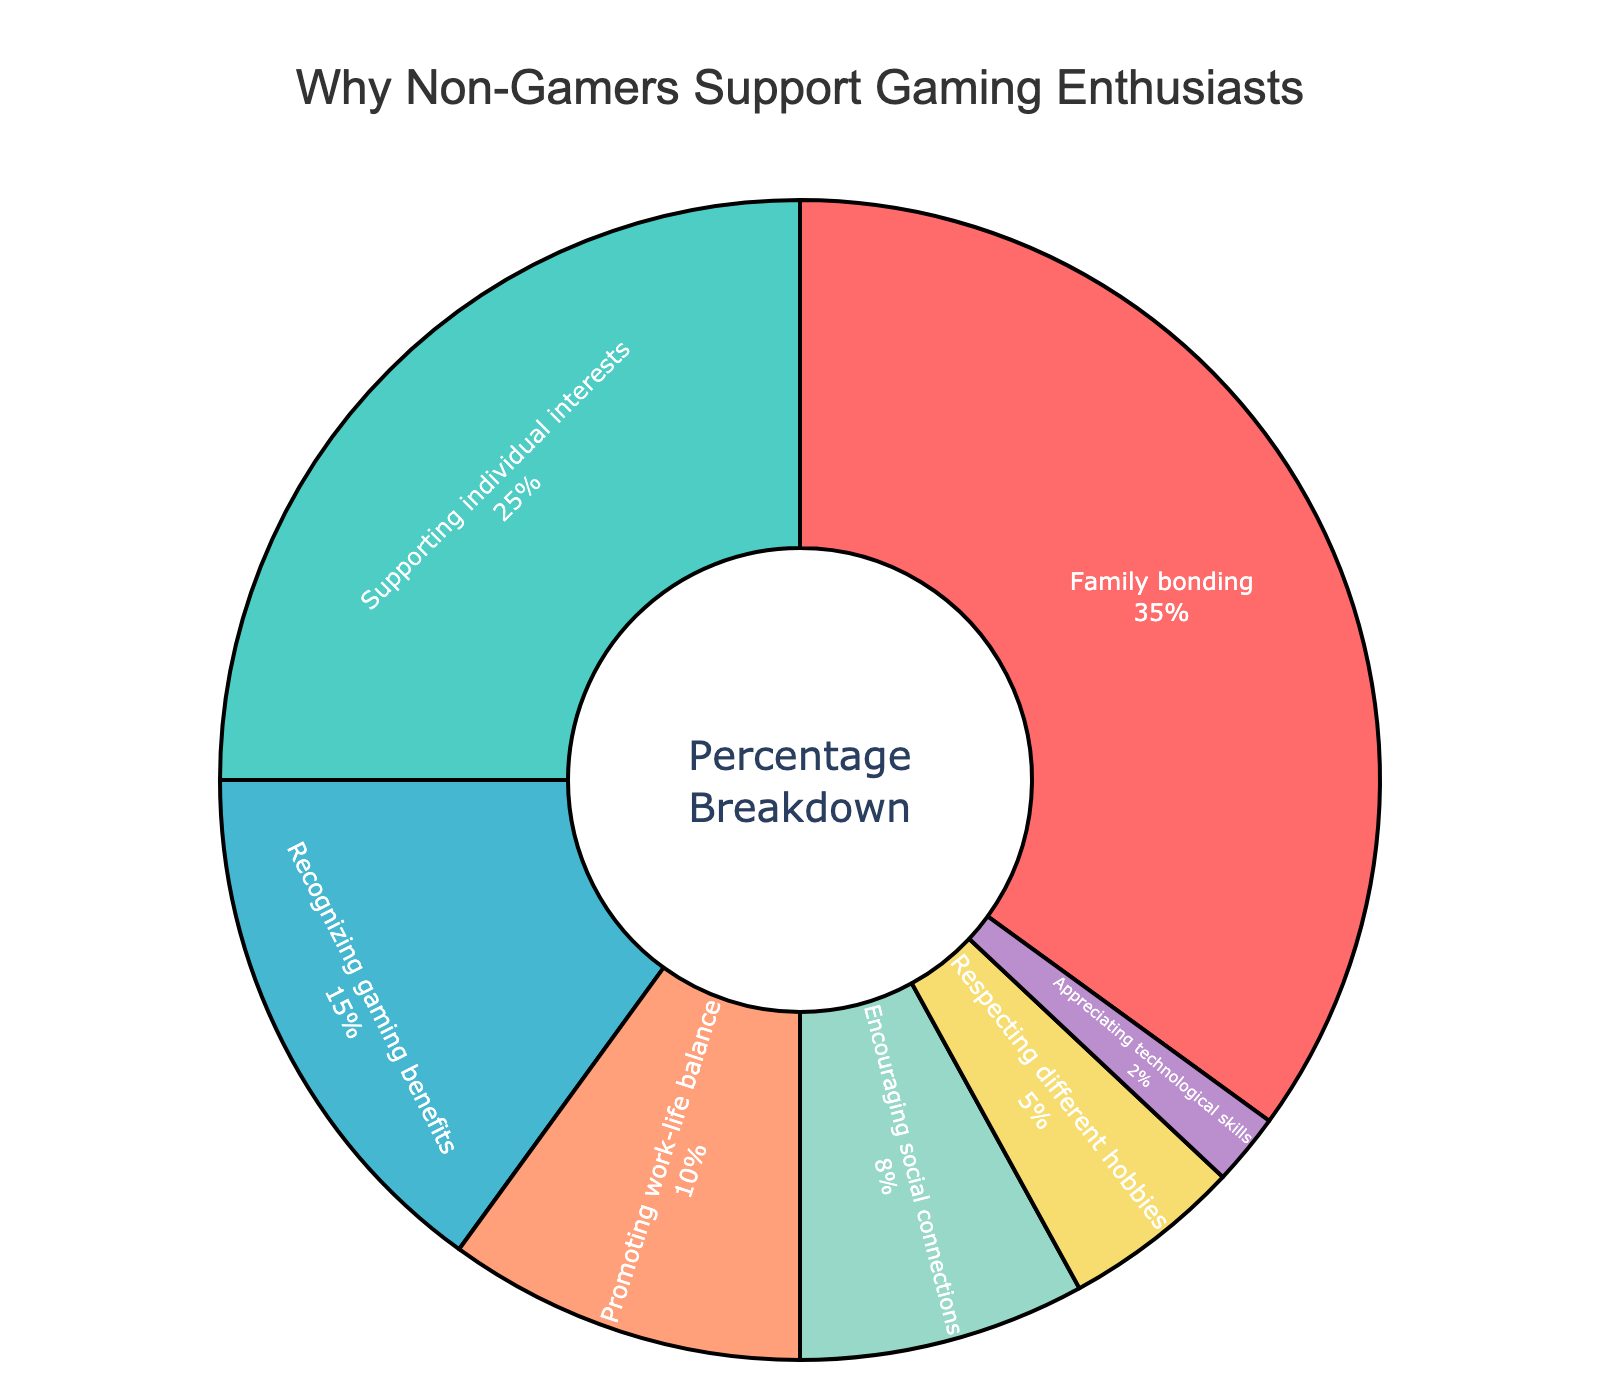What's the largest reason non-gamers support gaming enthusiasts? The largest portion in the pie chart is labeled "Family bonding," and it has a larger segment compared to the others.
Answer: Family bonding Which reason has the smallest percentage? The smallest segment of the pie chart is labeled "Appreciating technological skills," indicating it has the smallest percentage.
Answer: Appreciating technological skills How much more do non-gamers value family bonding compared to promoting work-life balance? The percentage for family bonding is 35%, and for promoting work-life balance, it is 10%. The difference is 35 - 10 = 25%.
Answer: 25% What two reasons combined make up the majority of the support? The two largest segments are for family bonding (35%) and supporting individual interests (25%). Their combined percentage is 35 + 25 = 60%, which is a majority.
Answer: Family bonding and supporting individual interests Compare the percentages for recognizing gaming benefits and encouraging social connections, which is higher and by how much? Recognizing gaming benefits has 15%, and encouraging social connections has 8%. The difference is 15 - 8 = 7%.
Answer: Recognizing gaming benefits by 7% What is the sum of the percentages for the smallest three categories? The smallest three categories are appreciating technological skills (2%), respecting different hobbies (5%), and encouraging social connections (8%). Their sum is 2 + 5 + 8 = 15%.
Answer: 15% If promoting work-life balance and recognizing gaming benefits are combined, what percentage do they make up together? Promoting work-life balance is 10%, and recognizing gaming benefits is 15%. Combined, they make up 10 + 15 = 25%.
Answer: 25% What percentage of the support is for reasons that help enhance personal skills (recognizing gaming benefits, appreciating technological skills)? Recognizing gaming benefits is 15%, and appreciating technological skills is 2%. Their combined percentage is 15 + 2 = 17%.
Answer: 17% 